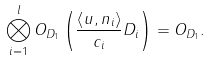Convert formula to latex. <formula><loc_0><loc_0><loc_500><loc_500>\bigotimes _ { i = 1 } ^ { l } O _ { D _ { 1 } } \left ( \frac { \left \langle u , n _ { i } \right \rangle } { c _ { i } } D _ { i } \right ) = O _ { D _ { 1 } } .</formula> 